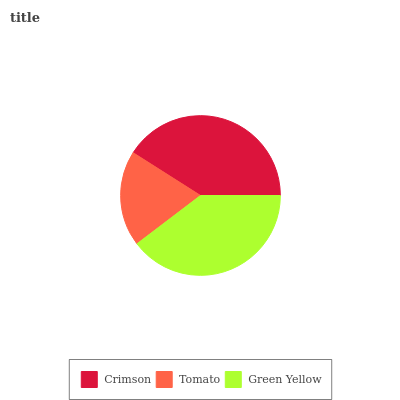Is Tomato the minimum?
Answer yes or no. Yes. Is Crimson the maximum?
Answer yes or no. Yes. Is Green Yellow the minimum?
Answer yes or no. No. Is Green Yellow the maximum?
Answer yes or no. No. Is Green Yellow greater than Tomato?
Answer yes or no. Yes. Is Tomato less than Green Yellow?
Answer yes or no. Yes. Is Tomato greater than Green Yellow?
Answer yes or no. No. Is Green Yellow less than Tomato?
Answer yes or no. No. Is Green Yellow the high median?
Answer yes or no. Yes. Is Green Yellow the low median?
Answer yes or no. Yes. Is Tomato the high median?
Answer yes or no. No. Is Crimson the low median?
Answer yes or no. No. 